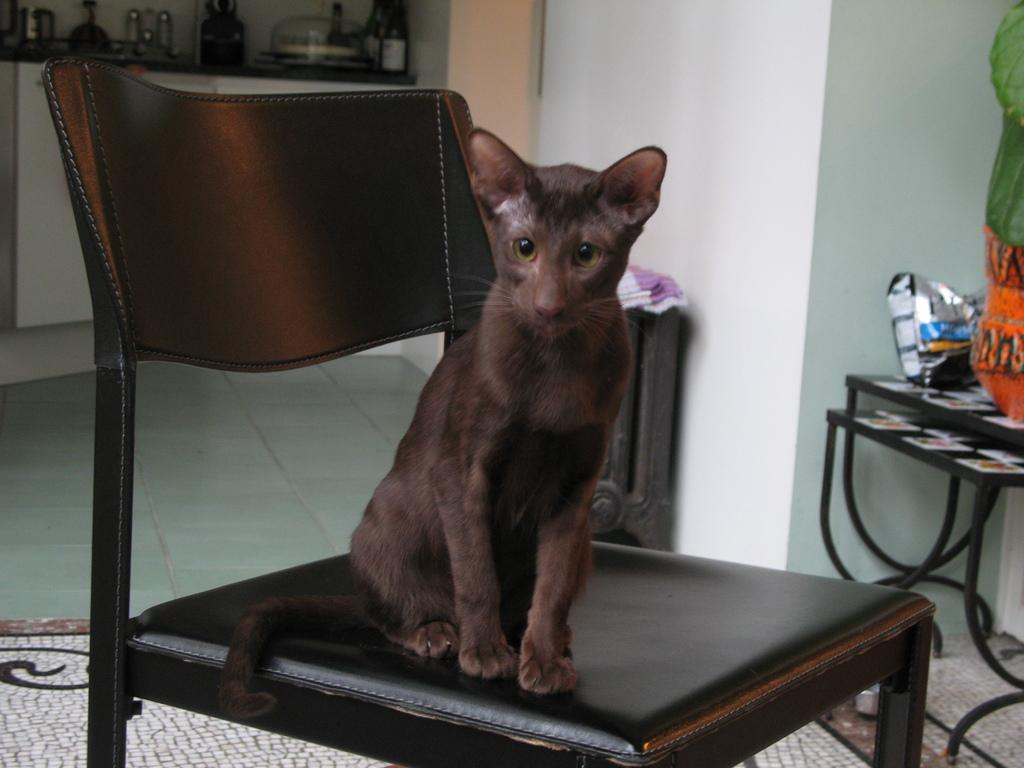What animal is sitting on a chair in the image? There is a cat sitting on a chair in the image. What can be seen on the right side of the image? There are objects on a table at the right side of the image. What is visible in the background of the image? There are objects in a cupboard in the background of the image. What is the health of the earth in the image? There is no reference to the earth or its health in the image; it features a cat sitting on a chair and objects on a table and in a cupboard. 